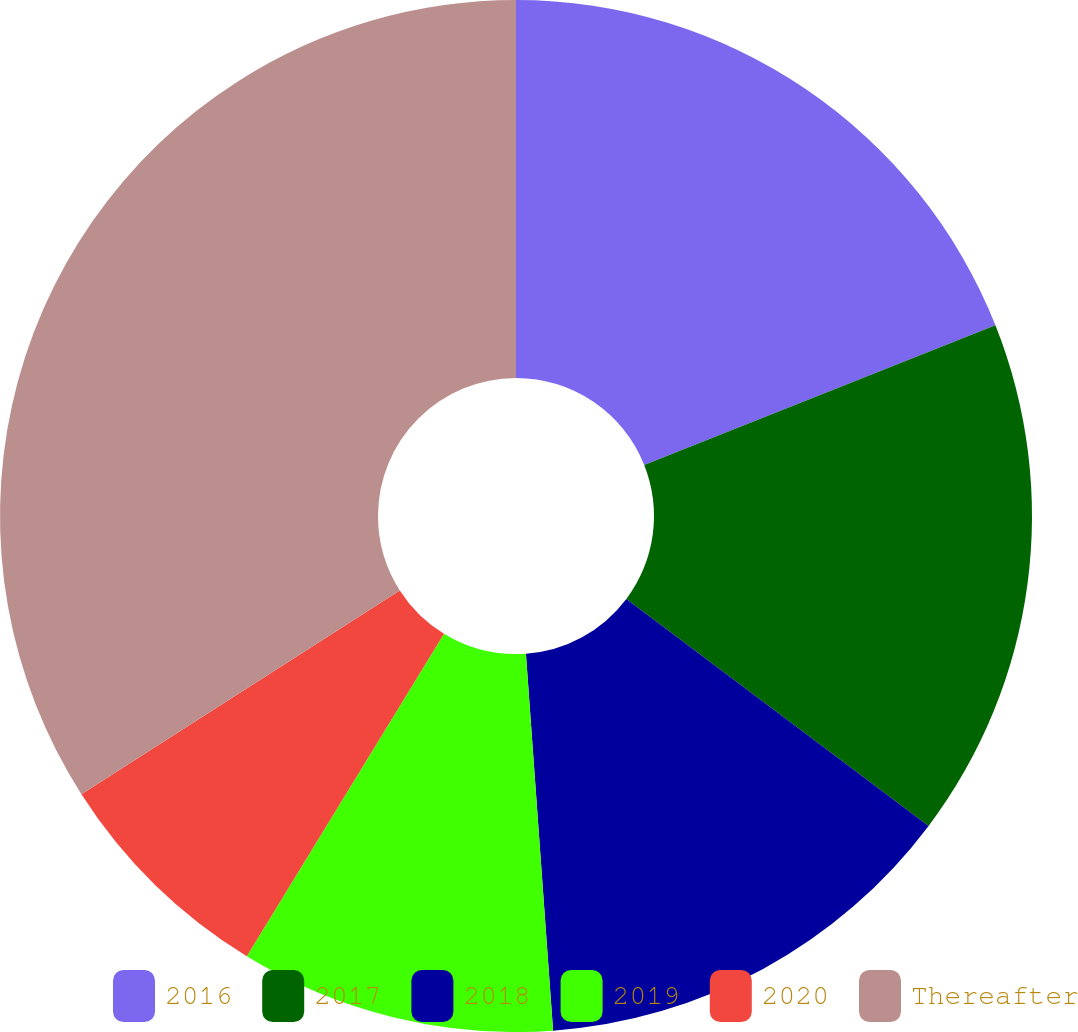Convert chart. <chart><loc_0><loc_0><loc_500><loc_500><pie_chart><fcel>2016<fcel>2017<fcel>2018<fcel>2019<fcel>2020<fcel>Thereafter<nl><fcel>18.97%<fcel>16.28%<fcel>13.6%<fcel>9.88%<fcel>7.2%<fcel>34.06%<nl></chart> 